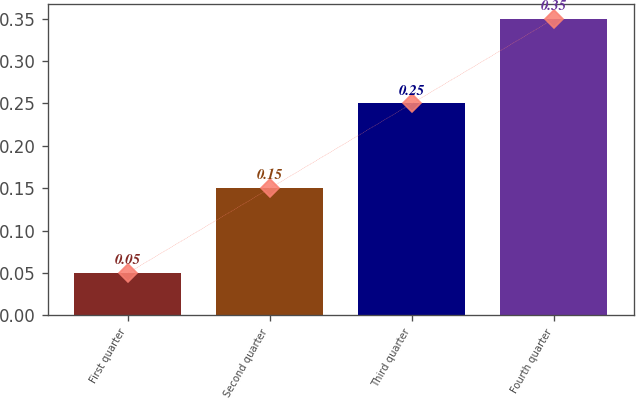<chart> <loc_0><loc_0><loc_500><loc_500><bar_chart><fcel>First quarter<fcel>Second quarter<fcel>Third quarter<fcel>Fourth quarter<nl><fcel>0.05<fcel>0.15<fcel>0.25<fcel>0.35<nl></chart> 